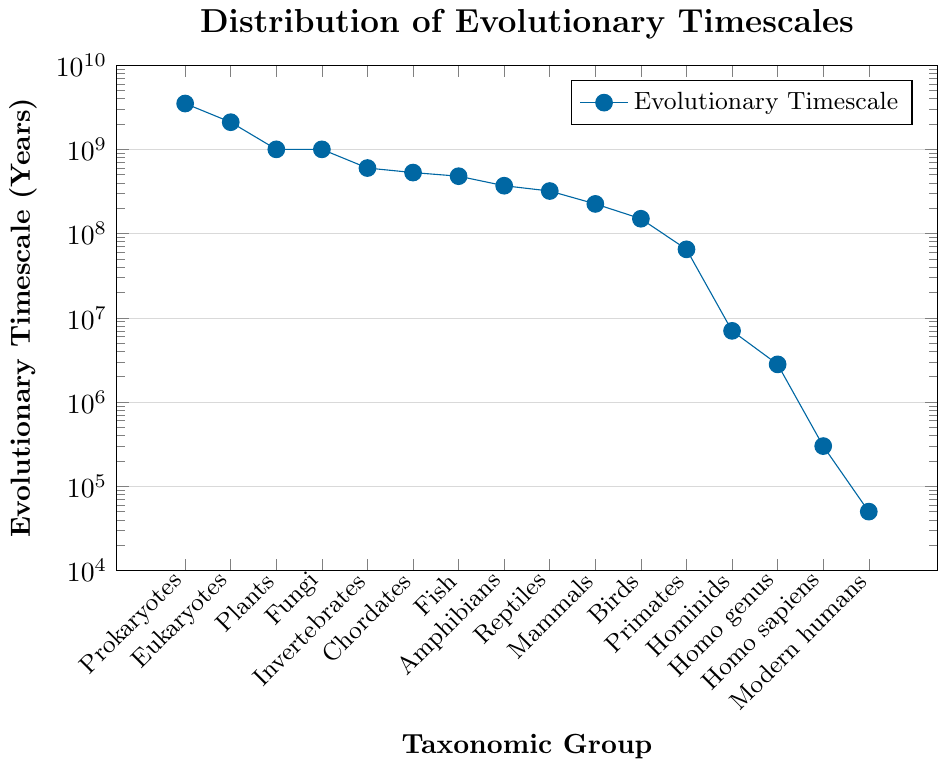What's the evolutionary timescale of Reptiles? According to the figure, find the Reptiles group on the x-axis and locate its corresponding point on the y-axis. The y-axis value for Reptiles is 320,000,000 years.
Answer: 320,000,000 years Which group has a shorter evolutionary timescale, Birds or Invertebrates? Locate Birds and Invertebrates on the x-axis. The y-axis value for Birds is 150,000,000 years, and for Invertebrates, it is 600,000,000 years. Since 150,000,000 is less than 600,000,000, Birds have a shorter timescale.
Answer: Birds What's the median evolutionary timescale of the groups shown on the plot? The data points ordered by timescale are: 50,000, 300,000, 2,800,000, 7,000,000, 65,000,000, 150,000,000, 225,000,000, 320,000,000, 370,000,000, 480,000,000, 530,000,000, 600,000,000, 1,000,000,000, 1,000,000,000, 2,100,000,000, 3,500,000,000. The median is the average of the 8th and 9th values: (3,700,000,000 + 4,800,000,000) / 2 = 425,000,000.
Answer: 425,000,000 years Compare the evolutionary timescales of Fungi and Homo sapiens. Which is greater and by how much? Locate Fungi and Homo sapiens on the x-axis. The y-axis value for Fungi is 1,000,000,000 years, and for Homo sapiens, it is 300,000 years. The difference is 1,000,000,000 - 300,000 = 999,700,000.
Answer: Fungi by 999,700,000 years Which taxonomic group evolved most recently? Find the group with the smallest y-axis value. Modern humans have the smallest y-axis value of 50,000 years, indicating they evolved most recently.
Answer: Modern humans Estimate the ratio of the evolutionary timescale of Homo genus to Primates. Find the y-axis values: Homo genus is 2,800,000 years and Primates is 65,000,000 years. The ratio is 2,800,000 / 65,000,000 ≈ 0.043.
Answer: 0.043 What is the sum of the evolutionary timescales for the groups within the range 100,000,000 to 500,000,000 years? Groups within this range are Fish (480,000,000), Amphibians (370,000,000), and Reptiles (320,000,000). Sum these values: 480,000,000 + 370,000,000 + 320,000,000 = 1,170,000,000.
Answer: 1,170,000,000 years Is the evolutionary timescale of Chordates greater than that of Invertebrates? Locate Chordates and Invertebrates on the x-axis. The y-axis value for Chordates is 530,000,000 years, and for Invertebrates, it is 600,000,000 years. Since 530,000,000 is less than 600,000,000, Chordates have a shorter timescale.
Answer: No What's the difference in the evolutionary timescale between Prokaryotes and Modern humans? Locate Prokaryotes and Modern humans on the x-axis. The y-axis value for Prokaryotes is 3,500,000,000 years, and for Modern humans, it is 50,000 years. The difference is 3,500,000,000 - 50,000 = 3,499,950,000 years.
Answer: 3,499,950,000 years 